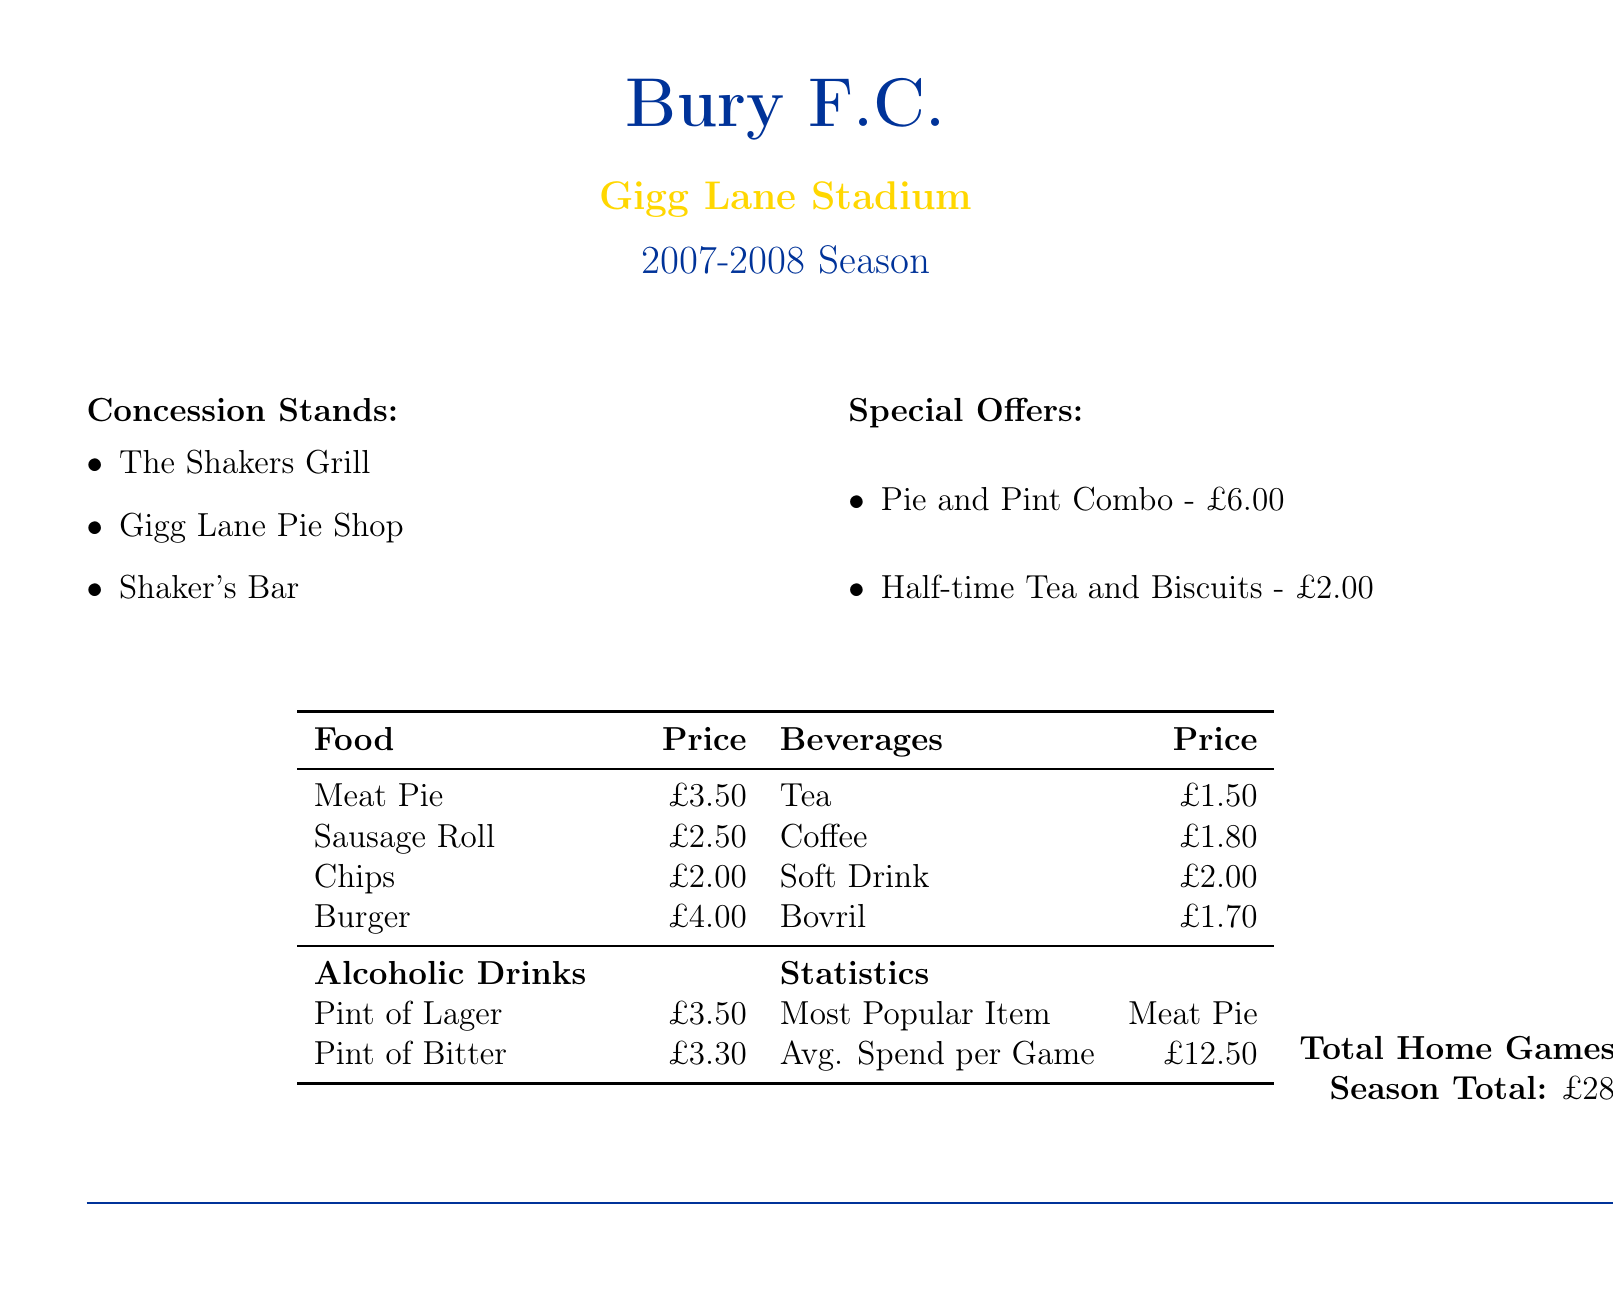What is the most popular item? The document states that the most popular item sold at the concession stands is the Meat Pie.
Answer: Meat Pie What is the total spent on food and beverages during the season? The document indicates that the total amount spent across all home games during the season is £287.50.
Answer: £287.50 How many home games were played? According to the document, the total number of home games played in the season is provided as 23.
Answer: 23 What is the price of a pint of lager? The document lists the price of a pint of lager as £3.50.
Answer: £3.50 What is the average spend per game? The average amount spent per game, as mentioned in the document, is £12.50.
Answer: £12.50 What special combo offer is available? The document mentions a special combo offer for a pie and pint for £6.00.
Answer: Pie and Pint Combo What type of food costs £2.00? Chips are listed in the document as costing £2.00.
Answer: Chips 